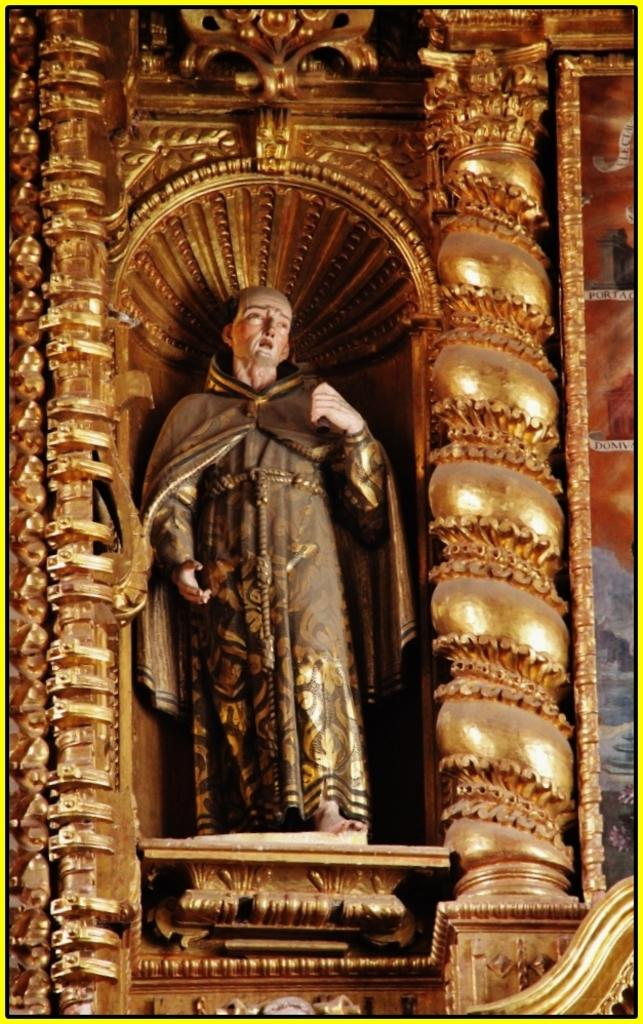What is the main subject of the image? There is a sculpture of a man in the image. What can be said about the color of the architecture in the image? The architecture in the image is gold in color. What type of books can be seen in the image? There are no books present in the image. What activity is the man in the sculpture engaged in? The sculpture is a static representation, so it is not engaged in any activity. 